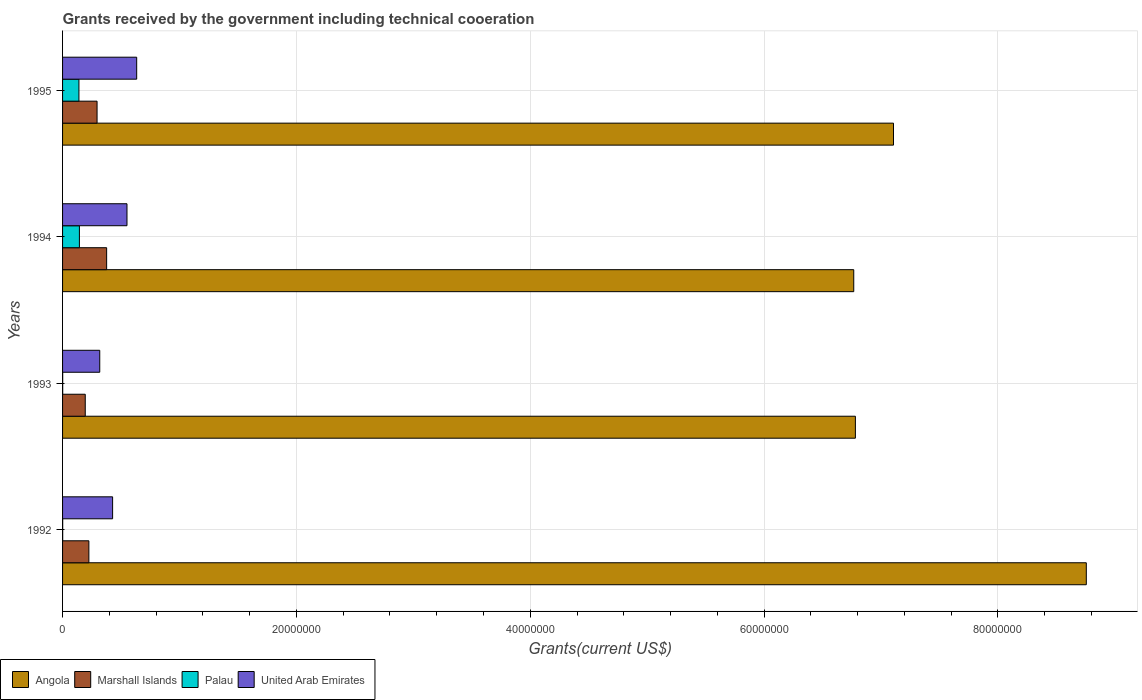How many different coloured bars are there?
Give a very brief answer. 4. Are the number of bars per tick equal to the number of legend labels?
Your answer should be compact. Yes. In how many cases, is the number of bars for a given year not equal to the number of legend labels?
Provide a short and direct response. 0. What is the total grants received by the government in United Arab Emirates in 1994?
Your response must be concise. 5.51e+06. Across all years, what is the maximum total grants received by the government in Palau?
Ensure brevity in your answer.  1.44e+06. Across all years, what is the minimum total grants received by the government in Marshall Islands?
Give a very brief answer. 1.94e+06. What is the total total grants received by the government in Palau in the graph?
Provide a short and direct response. 2.86e+06. What is the difference between the total grants received by the government in United Arab Emirates in 1994 and that in 1995?
Provide a short and direct response. -8.30e+05. What is the difference between the total grants received by the government in United Arab Emirates in 1994 and the total grants received by the government in Angola in 1992?
Your answer should be very brief. -8.20e+07. What is the average total grants received by the government in United Arab Emirates per year?
Provide a short and direct response. 4.83e+06. In the year 1993, what is the difference between the total grants received by the government in Angola and total grants received by the government in United Arab Emirates?
Your answer should be compact. 6.46e+07. What is the ratio of the total grants received by the government in United Arab Emirates in 1994 to that in 1995?
Your answer should be very brief. 0.87. Is the total grants received by the government in United Arab Emirates in 1992 less than that in 1994?
Provide a succinct answer. Yes. Is the difference between the total grants received by the government in Angola in 1992 and 1993 greater than the difference between the total grants received by the government in United Arab Emirates in 1992 and 1993?
Offer a terse response. Yes. What is the difference between the highest and the second highest total grants received by the government in United Arab Emirates?
Give a very brief answer. 8.30e+05. What is the difference between the highest and the lowest total grants received by the government in Palau?
Your answer should be very brief. 1.43e+06. What does the 2nd bar from the top in 1993 represents?
Keep it short and to the point. Palau. What does the 3rd bar from the bottom in 1995 represents?
Ensure brevity in your answer.  Palau. How many bars are there?
Keep it short and to the point. 16. Are all the bars in the graph horizontal?
Keep it short and to the point. Yes. How many years are there in the graph?
Keep it short and to the point. 4. Does the graph contain any zero values?
Your answer should be compact. No. How many legend labels are there?
Your answer should be very brief. 4. What is the title of the graph?
Your answer should be compact. Grants received by the government including technical cooeration. Does "Eritrea" appear as one of the legend labels in the graph?
Provide a succinct answer. No. What is the label or title of the X-axis?
Ensure brevity in your answer.  Grants(current US$). What is the label or title of the Y-axis?
Offer a terse response. Years. What is the Grants(current US$) of Angola in 1992?
Provide a succinct answer. 8.76e+07. What is the Grants(current US$) of Marshall Islands in 1992?
Provide a succinct answer. 2.25e+06. What is the Grants(current US$) of United Arab Emirates in 1992?
Ensure brevity in your answer.  4.28e+06. What is the Grants(current US$) in Angola in 1993?
Your answer should be compact. 6.78e+07. What is the Grants(current US$) of Marshall Islands in 1993?
Your response must be concise. 1.94e+06. What is the Grants(current US$) of United Arab Emirates in 1993?
Your response must be concise. 3.18e+06. What is the Grants(current US$) in Angola in 1994?
Your answer should be compact. 6.77e+07. What is the Grants(current US$) of Marshall Islands in 1994?
Make the answer very short. 3.77e+06. What is the Grants(current US$) in Palau in 1994?
Make the answer very short. 1.44e+06. What is the Grants(current US$) of United Arab Emirates in 1994?
Make the answer very short. 5.51e+06. What is the Grants(current US$) of Angola in 1995?
Provide a succinct answer. 7.11e+07. What is the Grants(current US$) in Marshall Islands in 1995?
Offer a very short reply. 2.95e+06. What is the Grants(current US$) of Palau in 1995?
Provide a short and direct response. 1.40e+06. What is the Grants(current US$) of United Arab Emirates in 1995?
Your answer should be compact. 6.34e+06. Across all years, what is the maximum Grants(current US$) of Angola?
Offer a very short reply. 8.76e+07. Across all years, what is the maximum Grants(current US$) in Marshall Islands?
Ensure brevity in your answer.  3.77e+06. Across all years, what is the maximum Grants(current US$) in Palau?
Your answer should be very brief. 1.44e+06. Across all years, what is the maximum Grants(current US$) in United Arab Emirates?
Make the answer very short. 6.34e+06. Across all years, what is the minimum Grants(current US$) in Angola?
Provide a succinct answer. 6.77e+07. Across all years, what is the minimum Grants(current US$) in Marshall Islands?
Ensure brevity in your answer.  1.94e+06. Across all years, what is the minimum Grants(current US$) of Palau?
Ensure brevity in your answer.  10000. Across all years, what is the minimum Grants(current US$) in United Arab Emirates?
Make the answer very short. 3.18e+06. What is the total Grants(current US$) of Angola in the graph?
Ensure brevity in your answer.  2.94e+08. What is the total Grants(current US$) of Marshall Islands in the graph?
Ensure brevity in your answer.  1.09e+07. What is the total Grants(current US$) of Palau in the graph?
Your answer should be compact. 2.86e+06. What is the total Grants(current US$) of United Arab Emirates in the graph?
Offer a very short reply. 1.93e+07. What is the difference between the Grants(current US$) of Angola in 1992 and that in 1993?
Ensure brevity in your answer.  1.98e+07. What is the difference between the Grants(current US$) in Palau in 1992 and that in 1993?
Keep it short and to the point. 0. What is the difference between the Grants(current US$) in United Arab Emirates in 1992 and that in 1993?
Make the answer very short. 1.10e+06. What is the difference between the Grants(current US$) of Angola in 1992 and that in 1994?
Offer a very short reply. 1.99e+07. What is the difference between the Grants(current US$) of Marshall Islands in 1992 and that in 1994?
Provide a succinct answer. -1.52e+06. What is the difference between the Grants(current US$) in Palau in 1992 and that in 1994?
Your answer should be compact. -1.43e+06. What is the difference between the Grants(current US$) in United Arab Emirates in 1992 and that in 1994?
Keep it short and to the point. -1.23e+06. What is the difference between the Grants(current US$) in Angola in 1992 and that in 1995?
Ensure brevity in your answer.  1.65e+07. What is the difference between the Grants(current US$) in Marshall Islands in 1992 and that in 1995?
Keep it short and to the point. -7.00e+05. What is the difference between the Grants(current US$) of Palau in 1992 and that in 1995?
Offer a terse response. -1.39e+06. What is the difference between the Grants(current US$) of United Arab Emirates in 1992 and that in 1995?
Make the answer very short. -2.06e+06. What is the difference between the Grants(current US$) of Marshall Islands in 1993 and that in 1994?
Your answer should be very brief. -1.83e+06. What is the difference between the Grants(current US$) in Palau in 1993 and that in 1994?
Your answer should be very brief. -1.43e+06. What is the difference between the Grants(current US$) in United Arab Emirates in 1993 and that in 1994?
Give a very brief answer. -2.33e+06. What is the difference between the Grants(current US$) of Angola in 1993 and that in 1995?
Give a very brief answer. -3.26e+06. What is the difference between the Grants(current US$) in Marshall Islands in 1993 and that in 1995?
Provide a short and direct response. -1.01e+06. What is the difference between the Grants(current US$) in Palau in 1993 and that in 1995?
Keep it short and to the point. -1.39e+06. What is the difference between the Grants(current US$) of United Arab Emirates in 1993 and that in 1995?
Make the answer very short. -3.16e+06. What is the difference between the Grants(current US$) of Angola in 1994 and that in 1995?
Offer a terse response. -3.40e+06. What is the difference between the Grants(current US$) in Marshall Islands in 1994 and that in 1995?
Provide a succinct answer. 8.20e+05. What is the difference between the Grants(current US$) of Palau in 1994 and that in 1995?
Offer a terse response. 4.00e+04. What is the difference between the Grants(current US$) in United Arab Emirates in 1994 and that in 1995?
Give a very brief answer. -8.30e+05. What is the difference between the Grants(current US$) of Angola in 1992 and the Grants(current US$) of Marshall Islands in 1993?
Keep it short and to the point. 8.56e+07. What is the difference between the Grants(current US$) in Angola in 1992 and the Grants(current US$) in Palau in 1993?
Offer a terse response. 8.76e+07. What is the difference between the Grants(current US$) in Angola in 1992 and the Grants(current US$) in United Arab Emirates in 1993?
Offer a very short reply. 8.44e+07. What is the difference between the Grants(current US$) of Marshall Islands in 1992 and the Grants(current US$) of Palau in 1993?
Provide a short and direct response. 2.24e+06. What is the difference between the Grants(current US$) of Marshall Islands in 1992 and the Grants(current US$) of United Arab Emirates in 1993?
Give a very brief answer. -9.30e+05. What is the difference between the Grants(current US$) of Palau in 1992 and the Grants(current US$) of United Arab Emirates in 1993?
Your answer should be very brief. -3.17e+06. What is the difference between the Grants(current US$) in Angola in 1992 and the Grants(current US$) in Marshall Islands in 1994?
Your answer should be compact. 8.38e+07. What is the difference between the Grants(current US$) in Angola in 1992 and the Grants(current US$) in Palau in 1994?
Ensure brevity in your answer.  8.61e+07. What is the difference between the Grants(current US$) of Angola in 1992 and the Grants(current US$) of United Arab Emirates in 1994?
Your response must be concise. 8.20e+07. What is the difference between the Grants(current US$) in Marshall Islands in 1992 and the Grants(current US$) in Palau in 1994?
Keep it short and to the point. 8.10e+05. What is the difference between the Grants(current US$) of Marshall Islands in 1992 and the Grants(current US$) of United Arab Emirates in 1994?
Give a very brief answer. -3.26e+06. What is the difference between the Grants(current US$) in Palau in 1992 and the Grants(current US$) in United Arab Emirates in 1994?
Your answer should be compact. -5.50e+06. What is the difference between the Grants(current US$) of Angola in 1992 and the Grants(current US$) of Marshall Islands in 1995?
Ensure brevity in your answer.  8.46e+07. What is the difference between the Grants(current US$) of Angola in 1992 and the Grants(current US$) of Palau in 1995?
Make the answer very short. 8.62e+07. What is the difference between the Grants(current US$) in Angola in 1992 and the Grants(current US$) in United Arab Emirates in 1995?
Offer a very short reply. 8.12e+07. What is the difference between the Grants(current US$) of Marshall Islands in 1992 and the Grants(current US$) of Palau in 1995?
Make the answer very short. 8.50e+05. What is the difference between the Grants(current US$) of Marshall Islands in 1992 and the Grants(current US$) of United Arab Emirates in 1995?
Your response must be concise. -4.09e+06. What is the difference between the Grants(current US$) of Palau in 1992 and the Grants(current US$) of United Arab Emirates in 1995?
Your answer should be very brief. -6.33e+06. What is the difference between the Grants(current US$) in Angola in 1993 and the Grants(current US$) in Marshall Islands in 1994?
Provide a short and direct response. 6.40e+07. What is the difference between the Grants(current US$) of Angola in 1993 and the Grants(current US$) of Palau in 1994?
Provide a short and direct response. 6.64e+07. What is the difference between the Grants(current US$) of Angola in 1993 and the Grants(current US$) of United Arab Emirates in 1994?
Provide a succinct answer. 6.23e+07. What is the difference between the Grants(current US$) in Marshall Islands in 1993 and the Grants(current US$) in Palau in 1994?
Ensure brevity in your answer.  5.00e+05. What is the difference between the Grants(current US$) in Marshall Islands in 1993 and the Grants(current US$) in United Arab Emirates in 1994?
Provide a succinct answer. -3.57e+06. What is the difference between the Grants(current US$) in Palau in 1993 and the Grants(current US$) in United Arab Emirates in 1994?
Provide a succinct answer. -5.50e+06. What is the difference between the Grants(current US$) in Angola in 1993 and the Grants(current US$) in Marshall Islands in 1995?
Keep it short and to the point. 6.49e+07. What is the difference between the Grants(current US$) in Angola in 1993 and the Grants(current US$) in Palau in 1995?
Offer a very short reply. 6.64e+07. What is the difference between the Grants(current US$) in Angola in 1993 and the Grants(current US$) in United Arab Emirates in 1995?
Your response must be concise. 6.15e+07. What is the difference between the Grants(current US$) in Marshall Islands in 1993 and the Grants(current US$) in Palau in 1995?
Offer a terse response. 5.40e+05. What is the difference between the Grants(current US$) in Marshall Islands in 1993 and the Grants(current US$) in United Arab Emirates in 1995?
Provide a succinct answer. -4.40e+06. What is the difference between the Grants(current US$) of Palau in 1993 and the Grants(current US$) of United Arab Emirates in 1995?
Give a very brief answer. -6.33e+06. What is the difference between the Grants(current US$) of Angola in 1994 and the Grants(current US$) of Marshall Islands in 1995?
Keep it short and to the point. 6.47e+07. What is the difference between the Grants(current US$) of Angola in 1994 and the Grants(current US$) of Palau in 1995?
Offer a terse response. 6.63e+07. What is the difference between the Grants(current US$) of Angola in 1994 and the Grants(current US$) of United Arab Emirates in 1995?
Give a very brief answer. 6.13e+07. What is the difference between the Grants(current US$) of Marshall Islands in 1994 and the Grants(current US$) of Palau in 1995?
Offer a very short reply. 2.37e+06. What is the difference between the Grants(current US$) of Marshall Islands in 1994 and the Grants(current US$) of United Arab Emirates in 1995?
Your response must be concise. -2.57e+06. What is the difference between the Grants(current US$) of Palau in 1994 and the Grants(current US$) of United Arab Emirates in 1995?
Offer a very short reply. -4.90e+06. What is the average Grants(current US$) of Angola per year?
Your answer should be very brief. 7.35e+07. What is the average Grants(current US$) in Marshall Islands per year?
Offer a terse response. 2.73e+06. What is the average Grants(current US$) in Palau per year?
Give a very brief answer. 7.15e+05. What is the average Grants(current US$) in United Arab Emirates per year?
Offer a very short reply. 4.83e+06. In the year 1992, what is the difference between the Grants(current US$) of Angola and Grants(current US$) of Marshall Islands?
Your answer should be compact. 8.53e+07. In the year 1992, what is the difference between the Grants(current US$) in Angola and Grants(current US$) in Palau?
Provide a short and direct response. 8.76e+07. In the year 1992, what is the difference between the Grants(current US$) of Angola and Grants(current US$) of United Arab Emirates?
Provide a short and direct response. 8.33e+07. In the year 1992, what is the difference between the Grants(current US$) in Marshall Islands and Grants(current US$) in Palau?
Keep it short and to the point. 2.24e+06. In the year 1992, what is the difference between the Grants(current US$) in Marshall Islands and Grants(current US$) in United Arab Emirates?
Your answer should be compact. -2.03e+06. In the year 1992, what is the difference between the Grants(current US$) in Palau and Grants(current US$) in United Arab Emirates?
Offer a very short reply. -4.27e+06. In the year 1993, what is the difference between the Grants(current US$) of Angola and Grants(current US$) of Marshall Islands?
Make the answer very short. 6.59e+07. In the year 1993, what is the difference between the Grants(current US$) of Angola and Grants(current US$) of Palau?
Give a very brief answer. 6.78e+07. In the year 1993, what is the difference between the Grants(current US$) of Angola and Grants(current US$) of United Arab Emirates?
Your response must be concise. 6.46e+07. In the year 1993, what is the difference between the Grants(current US$) of Marshall Islands and Grants(current US$) of Palau?
Ensure brevity in your answer.  1.93e+06. In the year 1993, what is the difference between the Grants(current US$) of Marshall Islands and Grants(current US$) of United Arab Emirates?
Offer a terse response. -1.24e+06. In the year 1993, what is the difference between the Grants(current US$) of Palau and Grants(current US$) of United Arab Emirates?
Provide a succinct answer. -3.17e+06. In the year 1994, what is the difference between the Grants(current US$) of Angola and Grants(current US$) of Marshall Islands?
Offer a very short reply. 6.39e+07. In the year 1994, what is the difference between the Grants(current US$) in Angola and Grants(current US$) in Palau?
Provide a short and direct response. 6.62e+07. In the year 1994, what is the difference between the Grants(current US$) of Angola and Grants(current US$) of United Arab Emirates?
Make the answer very short. 6.22e+07. In the year 1994, what is the difference between the Grants(current US$) of Marshall Islands and Grants(current US$) of Palau?
Your response must be concise. 2.33e+06. In the year 1994, what is the difference between the Grants(current US$) in Marshall Islands and Grants(current US$) in United Arab Emirates?
Your answer should be very brief. -1.74e+06. In the year 1994, what is the difference between the Grants(current US$) of Palau and Grants(current US$) of United Arab Emirates?
Your answer should be very brief. -4.07e+06. In the year 1995, what is the difference between the Grants(current US$) of Angola and Grants(current US$) of Marshall Islands?
Provide a succinct answer. 6.81e+07. In the year 1995, what is the difference between the Grants(current US$) in Angola and Grants(current US$) in Palau?
Give a very brief answer. 6.97e+07. In the year 1995, what is the difference between the Grants(current US$) of Angola and Grants(current US$) of United Arab Emirates?
Offer a terse response. 6.47e+07. In the year 1995, what is the difference between the Grants(current US$) of Marshall Islands and Grants(current US$) of Palau?
Keep it short and to the point. 1.55e+06. In the year 1995, what is the difference between the Grants(current US$) of Marshall Islands and Grants(current US$) of United Arab Emirates?
Provide a succinct answer. -3.39e+06. In the year 1995, what is the difference between the Grants(current US$) of Palau and Grants(current US$) of United Arab Emirates?
Give a very brief answer. -4.94e+06. What is the ratio of the Grants(current US$) in Angola in 1992 to that in 1993?
Provide a succinct answer. 1.29. What is the ratio of the Grants(current US$) in Marshall Islands in 1992 to that in 1993?
Make the answer very short. 1.16. What is the ratio of the Grants(current US$) of Palau in 1992 to that in 1993?
Give a very brief answer. 1. What is the ratio of the Grants(current US$) of United Arab Emirates in 1992 to that in 1993?
Give a very brief answer. 1.35. What is the ratio of the Grants(current US$) in Angola in 1992 to that in 1994?
Your answer should be compact. 1.29. What is the ratio of the Grants(current US$) of Marshall Islands in 1992 to that in 1994?
Keep it short and to the point. 0.6. What is the ratio of the Grants(current US$) of Palau in 1992 to that in 1994?
Your answer should be compact. 0.01. What is the ratio of the Grants(current US$) in United Arab Emirates in 1992 to that in 1994?
Your response must be concise. 0.78. What is the ratio of the Grants(current US$) of Angola in 1992 to that in 1995?
Provide a short and direct response. 1.23. What is the ratio of the Grants(current US$) in Marshall Islands in 1992 to that in 1995?
Give a very brief answer. 0.76. What is the ratio of the Grants(current US$) of Palau in 1992 to that in 1995?
Offer a very short reply. 0.01. What is the ratio of the Grants(current US$) of United Arab Emirates in 1992 to that in 1995?
Your answer should be compact. 0.68. What is the ratio of the Grants(current US$) in Marshall Islands in 1993 to that in 1994?
Provide a succinct answer. 0.51. What is the ratio of the Grants(current US$) in Palau in 1993 to that in 1994?
Keep it short and to the point. 0.01. What is the ratio of the Grants(current US$) of United Arab Emirates in 1993 to that in 1994?
Ensure brevity in your answer.  0.58. What is the ratio of the Grants(current US$) of Angola in 1993 to that in 1995?
Your answer should be very brief. 0.95. What is the ratio of the Grants(current US$) of Marshall Islands in 1993 to that in 1995?
Offer a very short reply. 0.66. What is the ratio of the Grants(current US$) in Palau in 1993 to that in 1995?
Your answer should be very brief. 0.01. What is the ratio of the Grants(current US$) in United Arab Emirates in 1993 to that in 1995?
Provide a short and direct response. 0.5. What is the ratio of the Grants(current US$) of Angola in 1994 to that in 1995?
Provide a succinct answer. 0.95. What is the ratio of the Grants(current US$) in Marshall Islands in 1994 to that in 1995?
Offer a very short reply. 1.28. What is the ratio of the Grants(current US$) of Palau in 1994 to that in 1995?
Ensure brevity in your answer.  1.03. What is the ratio of the Grants(current US$) of United Arab Emirates in 1994 to that in 1995?
Keep it short and to the point. 0.87. What is the difference between the highest and the second highest Grants(current US$) in Angola?
Keep it short and to the point. 1.65e+07. What is the difference between the highest and the second highest Grants(current US$) of Marshall Islands?
Your answer should be compact. 8.20e+05. What is the difference between the highest and the second highest Grants(current US$) in Palau?
Offer a terse response. 4.00e+04. What is the difference between the highest and the second highest Grants(current US$) in United Arab Emirates?
Make the answer very short. 8.30e+05. What is the difference between the highest and the lowest Grants(current US$) in Angola?
Your answer should be compact. 1.99e+07. What is the difference between the highest and the lowest Grants(current US$) in Marshall Islands?
Your answer should be very brief. 1.83e+06. What is the difference between the highest and the lowest Grants(current US$) of Palau?
Provide a succinct answer. 1.43e+06. What is the difference between the highest and the lowest Grants(current US$) in United Arab Emirates?
Provide a succinct answer. 3.16e+06. 